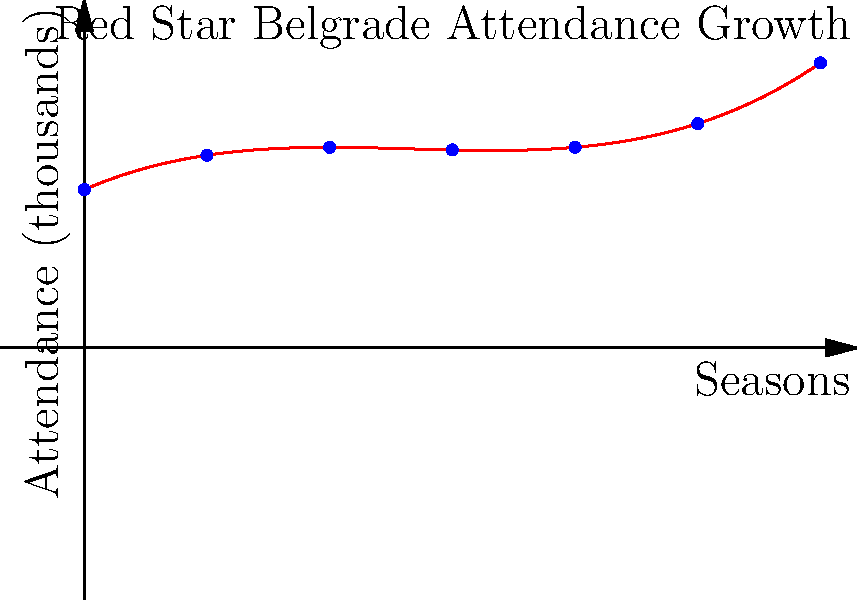The graph above shows the polynomial regression of Red Star Belgrade's match attendance (in thousands) over six seasons. Which season showed the highest attendance, and what was the approximate attendance figure? To solve this problem, we need to follow these steps:

1. Observe that the graph represents a cubic function, as it has one inflection point.
2. The x-axis represents seasons (0 to 6), and the y-axis represents attendance in thousands.
3. To find the highest attendance, we need to locate the maximum point on the curve.
4. By visual inspection, we can see that the curve reaches its peak around x = 5.
5. To find the approximate attendance, we need to read the y-value at x = 5.
6. The y-value at x = 5 appears to be slightly above 40 on the graph.

Therefore, the highest attendance was in Season 5, with approximately 41,000 fans.
Answer: Season 5, approximately 41,000 fans 